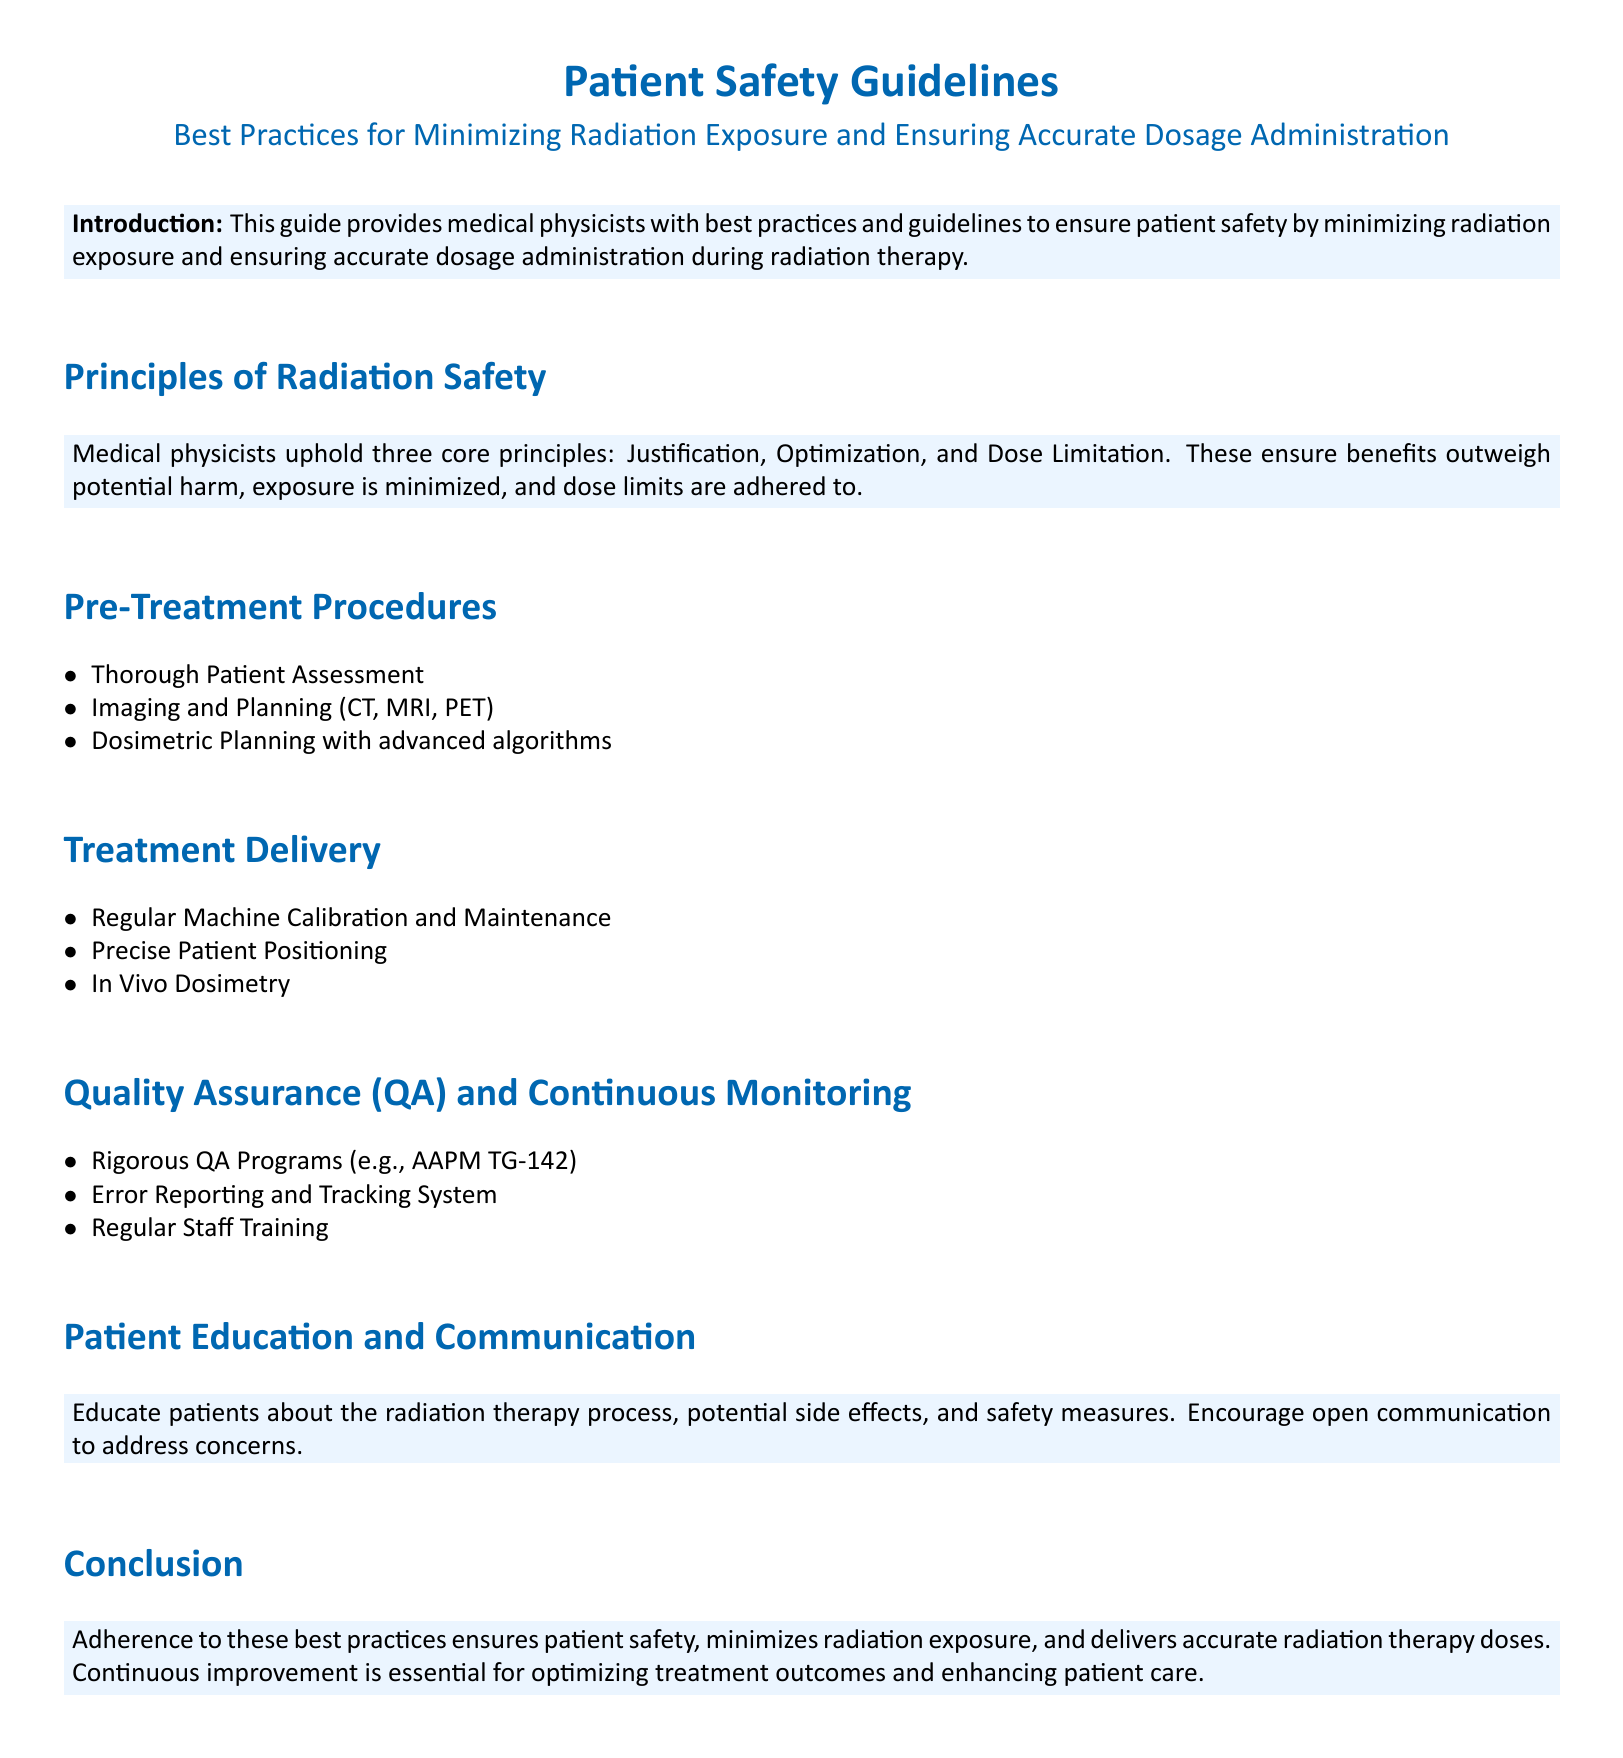What are the three core principles of radiation safety? The three core principles of radiation safety are justification, optimization, and dose limitation.
Answer: justification, optimization, dose limitation What does QA stand for in the context of this document? QA stands for Quality Assurance, which is a critical component in ensuring accurate radiation delivery.
Answer: Quality Assurance What should be included in patient education according to the document? The document states that patients should be educated about the radiation therapy process, potential side effects, and safety measures.
Answer: radiation therapy process, potential side effects, safety measures What is recommended for treatment delivery regarding patient positioning? The document emphasizes the importance of precise patient positioning during treatment delivery to ensure accuracy.
Answer: precise patient positioning How often should staff training take place? Regular staff training is emphasized as a component of the Quality Assurance programs. The frequency is not specified, but the term "regular" implies consistency.
Answer: regular What is the purpose of the Error Reporting and Tracking System? The purpose of the Error Reporting and Tracking System is to enhance safety by monitoring errors and tracking them systematically.
Answer: enhance safety What is the primary outcome of adhering to best practices in radiation therapy? Adherence to best practices ensures patient safety, minimizes radiation exposure, and delivers accurate radiation therapy doses.
Answer: patient safety, minimizes radiation exposure, accurate radiation therapy doses What technology is mentioned for dosimetric planning? The document mentions advanced algorithms for dosimetric planning.
Answer: advanced algorithms 